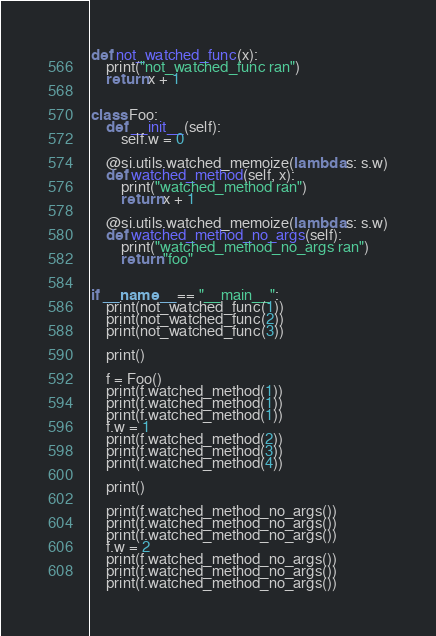Convert code to text. <code><loc_0><loc_0><loc_500><loc_500><_Python_>
def not_watched_func(x):
    print("not_watched_func ran")
    return x + 1


class Foo:
    def __init__(self):
        self.w = 0

    @si.utils.watched_memoize(lambda s: s.w)
    def watched_method(self, x):
        print("watched_method ran")
        return x + 1

    @si.utils.watched_memoize(lambda s: s.w)
    def watched_method_no_args(self):
        print("watched_method_no_args ran")
        return "foo"


if __name__ == "__main__":
    print(not_watched_func(1))
    print(not_watched_func(2))
    print(not_watched_func(3))

    print()

    f = Foo()
    print(f.watched_method(1))
    print(f.watched_method(1))
    print(f.watched_method(1))
    f.w = 1
    print(f.watched_method(2))
    print(f.watched_method(3))
    print(f.watched_method(4))

    print()

    print(f.watched_method_no_args())
    print(f.watched_method_no_args())
    print(f.watched_method_no_args())
    f.w = 2
    print(f.watched_method_no_args())
    print(f.watched_method_no_args())
    print(f.watched_method_no_args())
</code> 